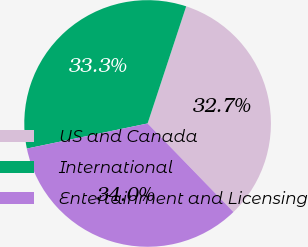<chart> <loc_0><loc_0><loc_500><loc_500><pie_chart><fcel>US and Canada<fcel>International<fcel>Entertainment and Licensing<nl><fcel>32.68%<fcel>33.33%<fcel>33.99%<nl></chart> 